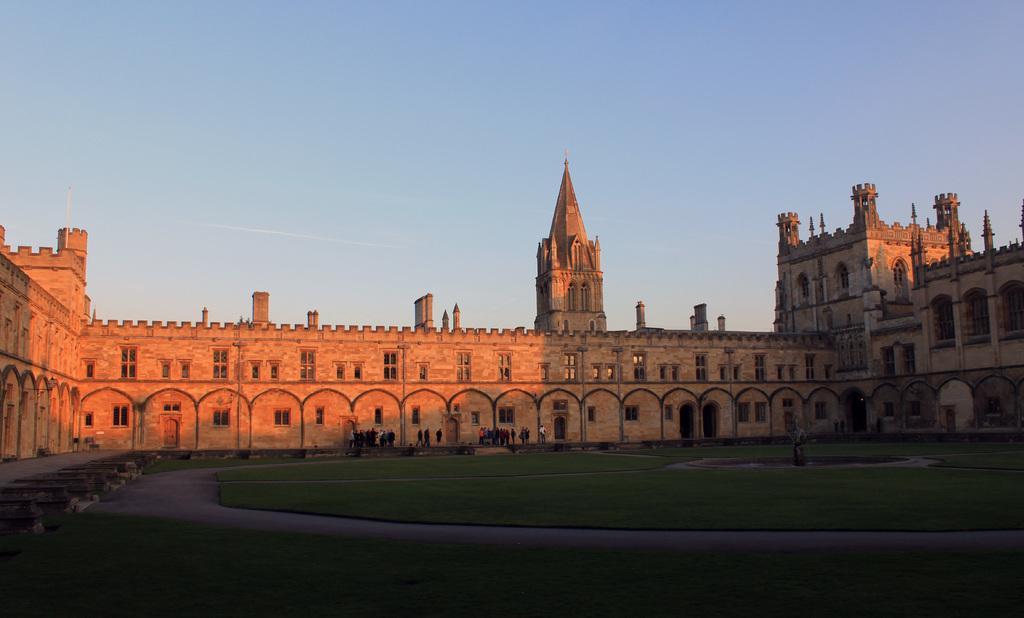Can you describe this image briefly? In this image, we can see a building, we can see some windows and there's grass on the ground, there is a way, we can see some people standing, at the top there is a sky. 